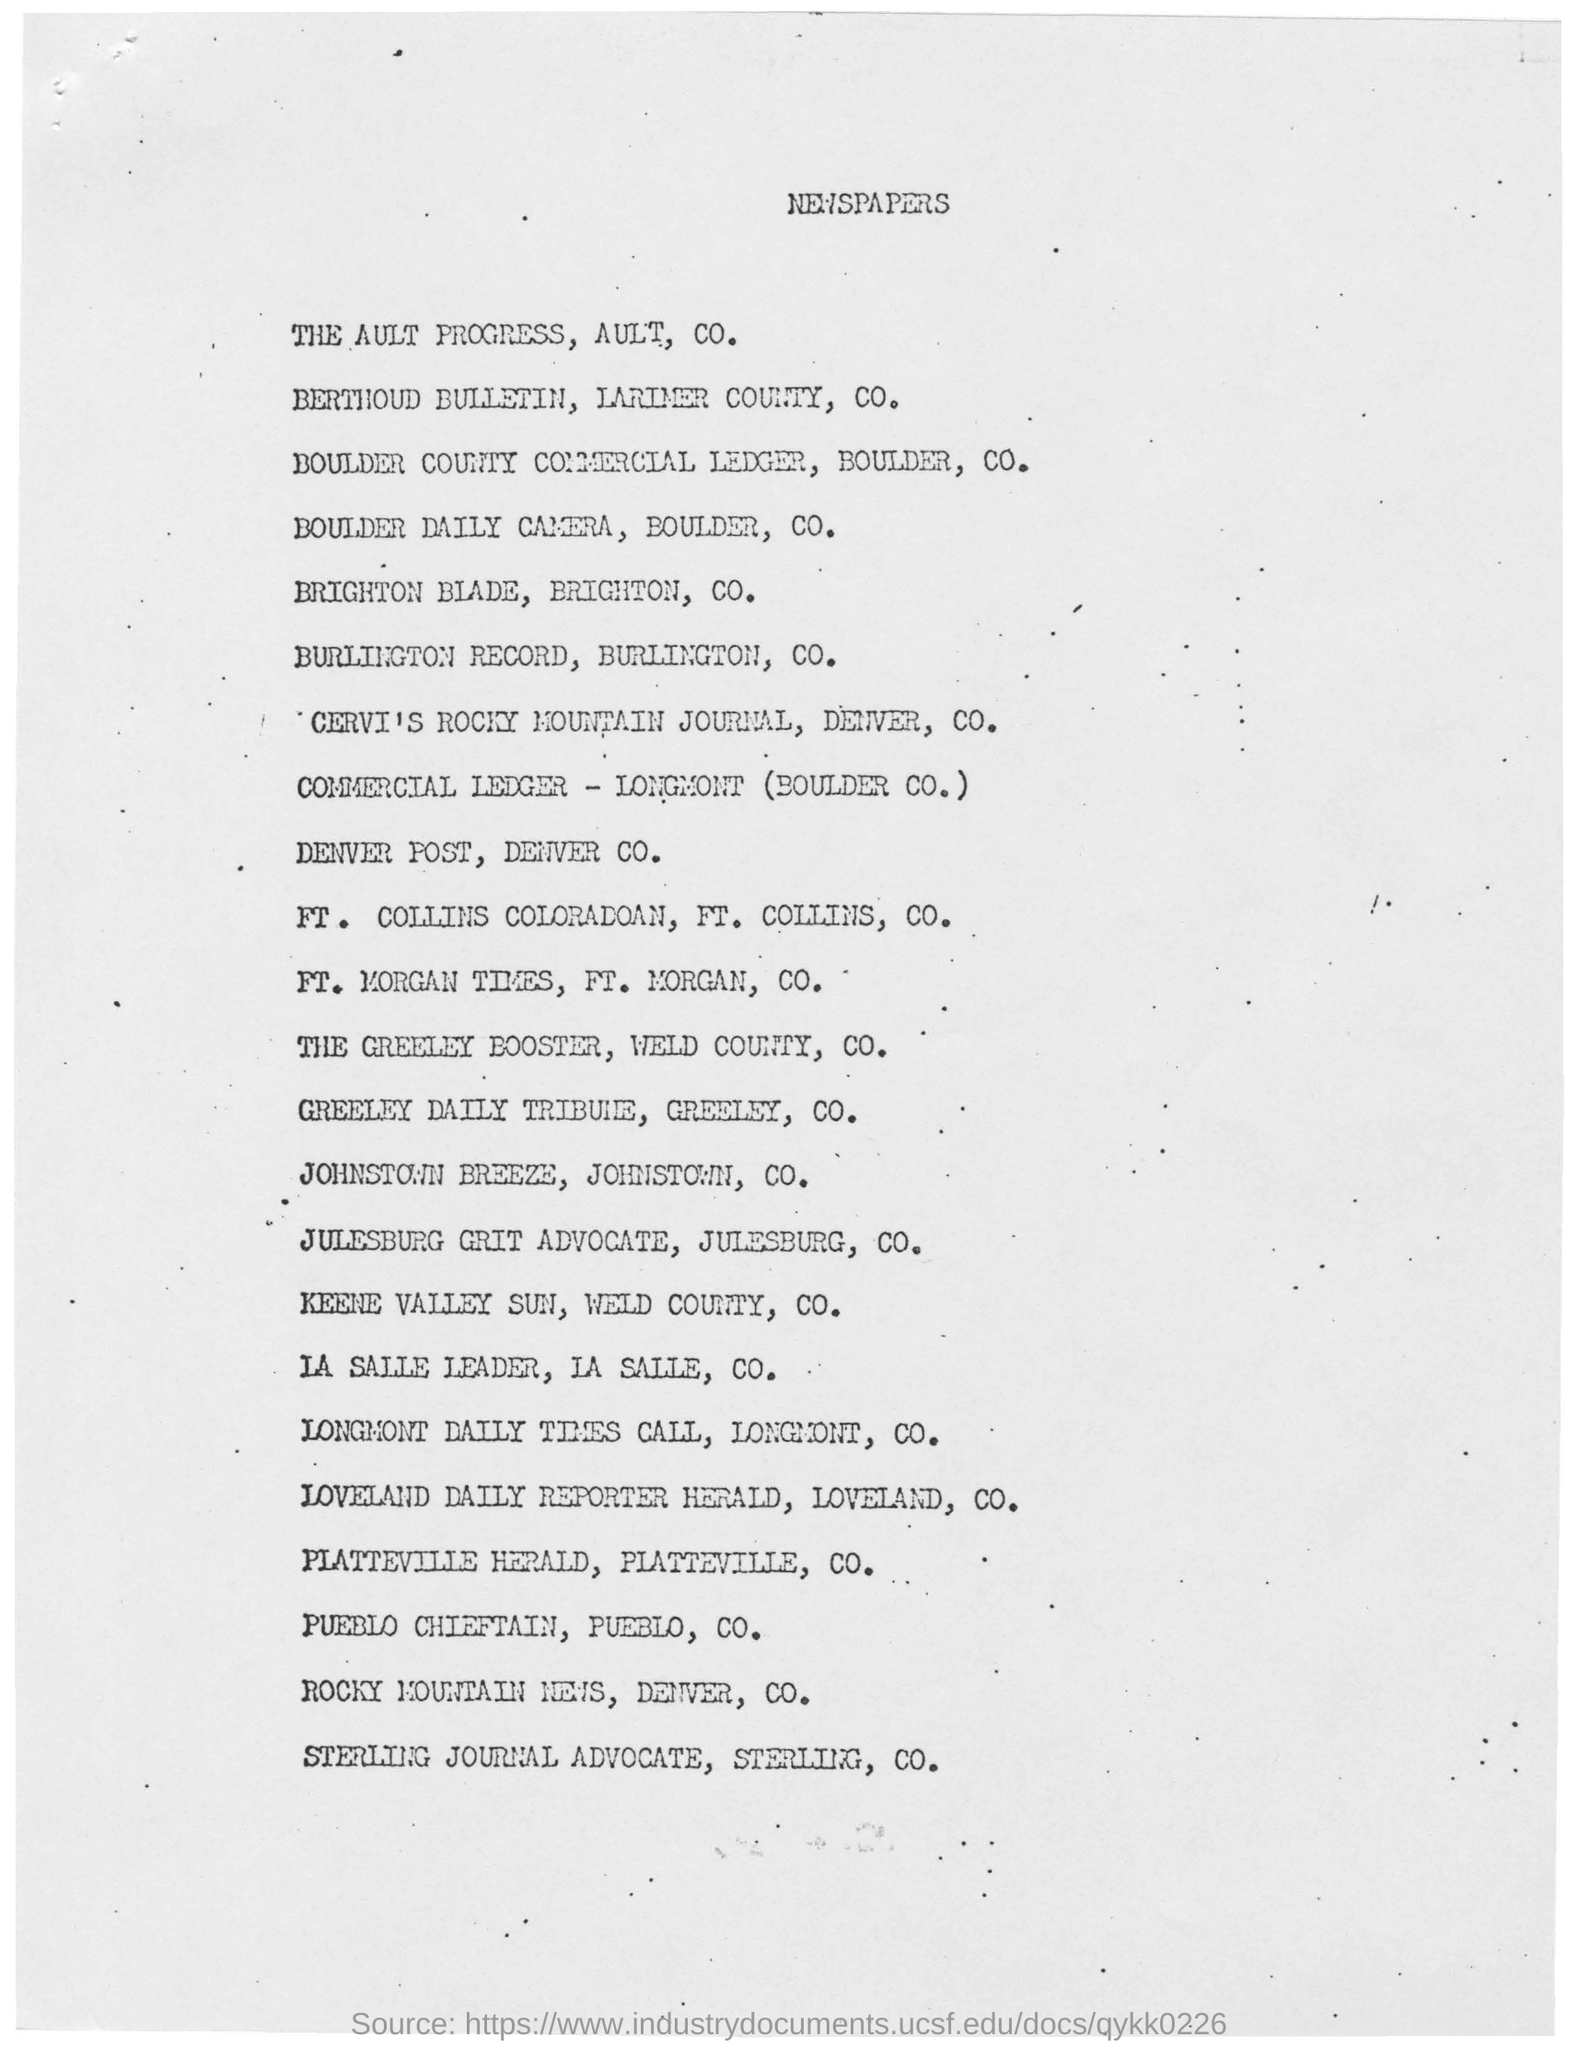Outline some significant characteristics in this image. The headline of this document is NEWSPAPERS. 